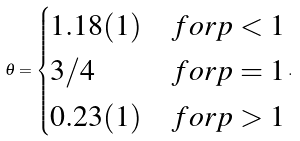Convert formula to latex. <formula><loc_0><loc_0><loc_500><loc_500>\theta = \begin{cases} 1 . 1 8 ( 1 ) & f o r p < 1 \\ 3 / 4 & f o r p = 1 \\ 0 . 2 3 ( 1 ) & f o r p > 1 \end{cases} .</formula> 